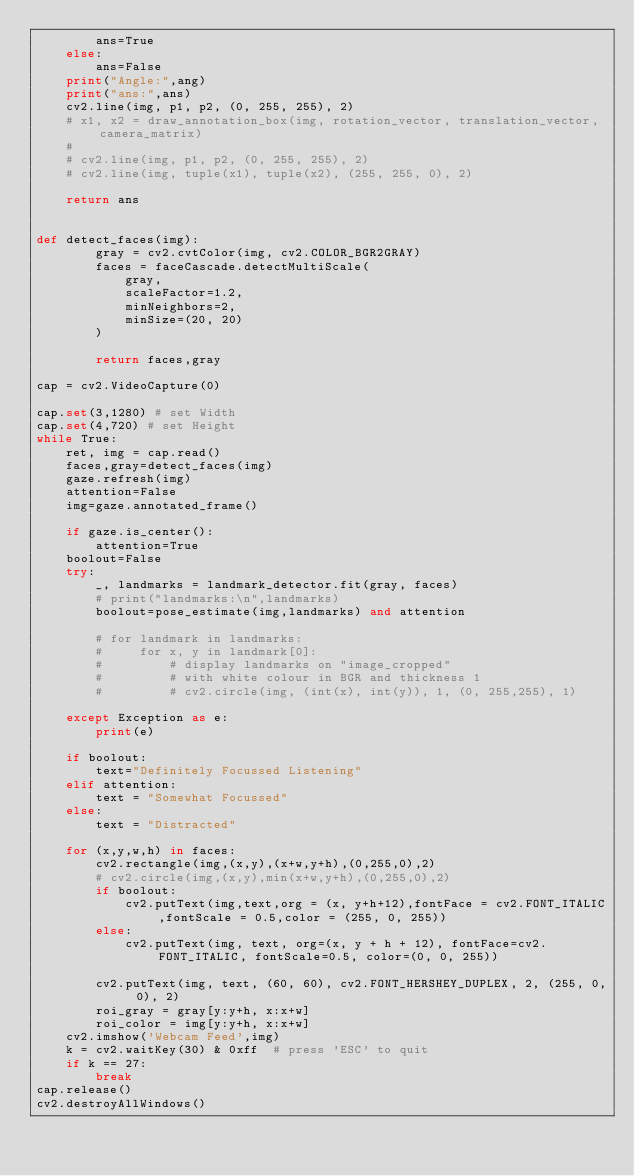Convert code to text. <code><loc_0><loc_0><loc_500><loc_500><_Python_>        ans=True
    else:
        ans=False
    print("Angle:",ang)
    print("ans:",ans)
    cv2.line(img, p1, p2, (0, 255, 255), 2)
    # x1, x2 = draw_annotation_box(img, rotation_vector, translation_vector, camera_matrix)
    #
    # cv2.line(img, p1, p2, (0, 255, 255), 2)
    # cv2.line(img, tuple(x1), tuple(x2), (255, 255, 0), 2)

    return ans


def detect_faces(img):
        gray = cv2.cvtColor(img, cv2.COLOR_BGR2GRAY)
        faces = faceCascade.detectMultiScale(
            gray,
            scaleFactor=1.2,
            minNeighbors=2,
            minSize=(20, 20)
        )

        return faces,gray

cap = cv2.VideoCapture(0)

cap.set(3,1280) # set Width
cap.set(4,720) # set Height
while True:
    ret, img = cap.read()
    faces,gray=detect_faces(img)
    gaze.refresh(img)
    attention=False
    img=gaze.annotated_frame()

    if gaze.is_center():
        attention=True
    boolout=False
    try:
        _, landmarks = landmark_detector.fit(gray, faces)
        # print("landmarks:\n",landmarks)
        boolout=pose_estimate(img,landmarks) and attention

        # for landmark in landmarks:
        #     for x, y in landmark[0]:
        #         # display landmarks on "image_cropped"
        #         # with white colour in BGR and thickness 1
        #         # cv2.circle(img, (int(x), int(y)), 1, (0, 255,255), 1)

    except Exception as e:
        print(e)

    if boolout:
        text="Definitely Focussed Listening"
    elif attention:
        text = "Somewhat Focussed"
    else:
        text = "Distracted"

    for (x,y,w,h) in faces:
        cv2.rectangle(img,(x,y),(x+w,y+h),(0,255,0),2)
        # cv2.circle(img,(x,y),min(x+w,y+h),(0,255,0),2)
        if boolout:
            cv2.putText(img,text,org = (x, y+h+12),fontFace = cv2.FONT_ITALIC,fontScale = 0.5,color = (255, 0, 255))
        else:
            cv2.putText(img, text, org=(x, y + h + 12), fontFace=cv2.FONT_ITALIC, fontScale=0.5, color=(0, 0, 255))

        cv2.putText(img, text, (60, 60), cv2.FONT_HERSHEY_DUPLEX, 2, (255, 0, 0), 2)
        roi_gray = gray[y:y+h, x:x+w]
        roi_color = img[y:y+h, x:x+w]
    cv2.imshow('Webcam Feed',img)
    k = cv2.waitKey(30) & 0xff  # press 'ESC' to quit
    if k == 27:
        break
cap.release()
cv2.destroyAllWindows()</code> 